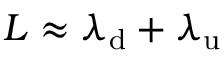Convert formula to latex. <formula><loc_0><loc_0><loc_500><loc_500>L \approx \lambda _ { d } + \lambda _ { u }</formula> 